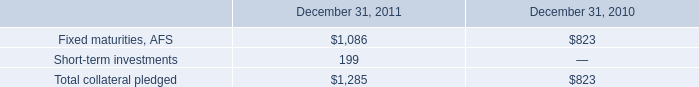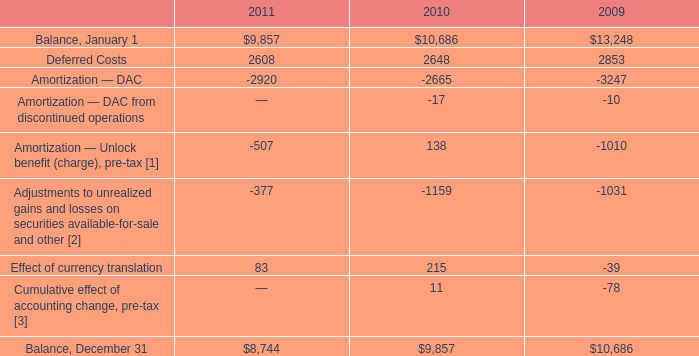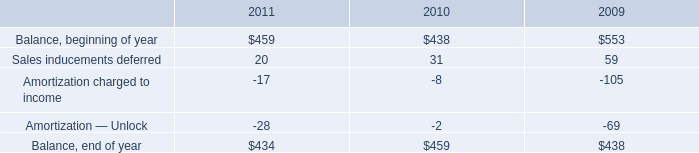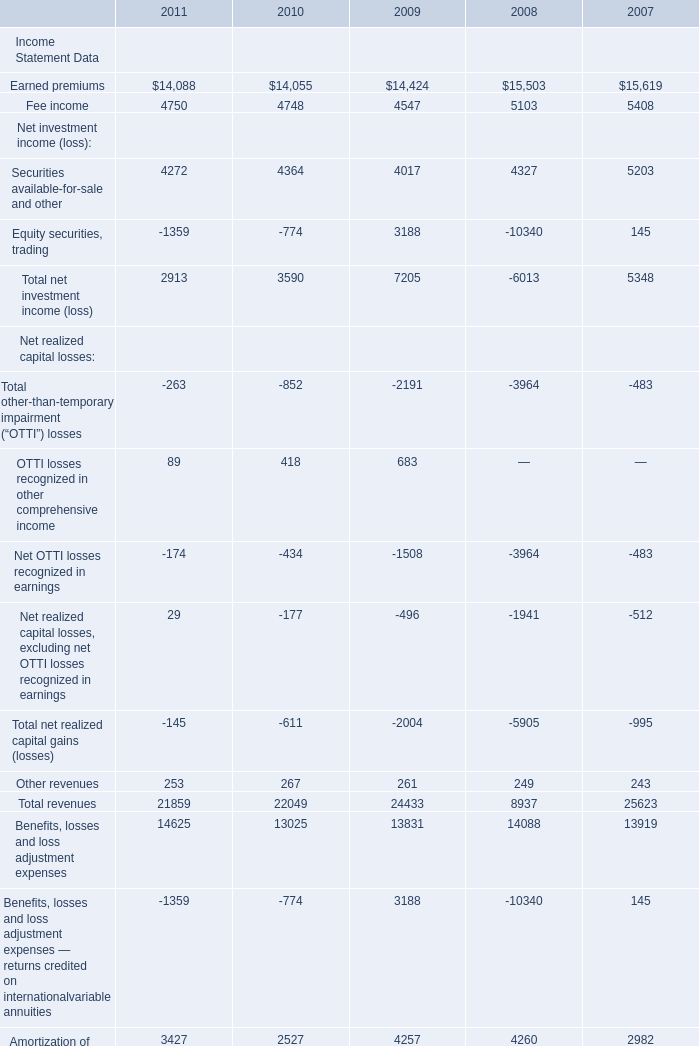What is the growing rate of Interest expense in the year with the most Other revenues? 
Computations: ((508 - 476) / 476)
Answer: 0.06723. 